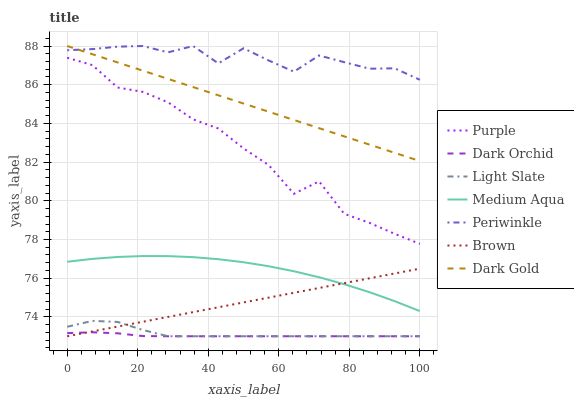Does Dark Orchid have the minimum area under the curve?
Answer yes or no. Yes. Does Periwinkle have the maximum area under the curve?
Answer yes or no. Yes. Does Dark Gold have the minimum area under the curve?
Answer yes or no. No. Does Dark Gold have the maximum area under the curve?
Answer yes or no. No. Is Brown the smoothest?
Answer yes or no. Yes. Is Purple the roughest?
Answer yes or no. Yes. Is Dark Gold the smoothest?
Answer yes or no. No. Is Dark Gold the roughest?
Answer yes or no. No. Does Brown have the lowest value?
Answer yes or no. Yes. Does Dark Gold have the lowest value?
Answer yes or no. No. Does Periwinkle have the highest value?
Answer yes or no. Yes. Does Purple have the highest value?
Answer yes or no. No. Is Dark Orchid less than Dark Gold?
Answer yes or no. Yes. Is Dark Gold greater than Dark Orchid?
Answer yes or no. Yes. Does Brown intersect Light Slate?
Answer yes or no. Yes. Is Brown less than Light Slate?
Answer yes or no. No. Is Brown greater than Light Slate?
Answer yes or no. No. Does Dark Orchid intersect Dark Gold?
Answer yes or no. No. 